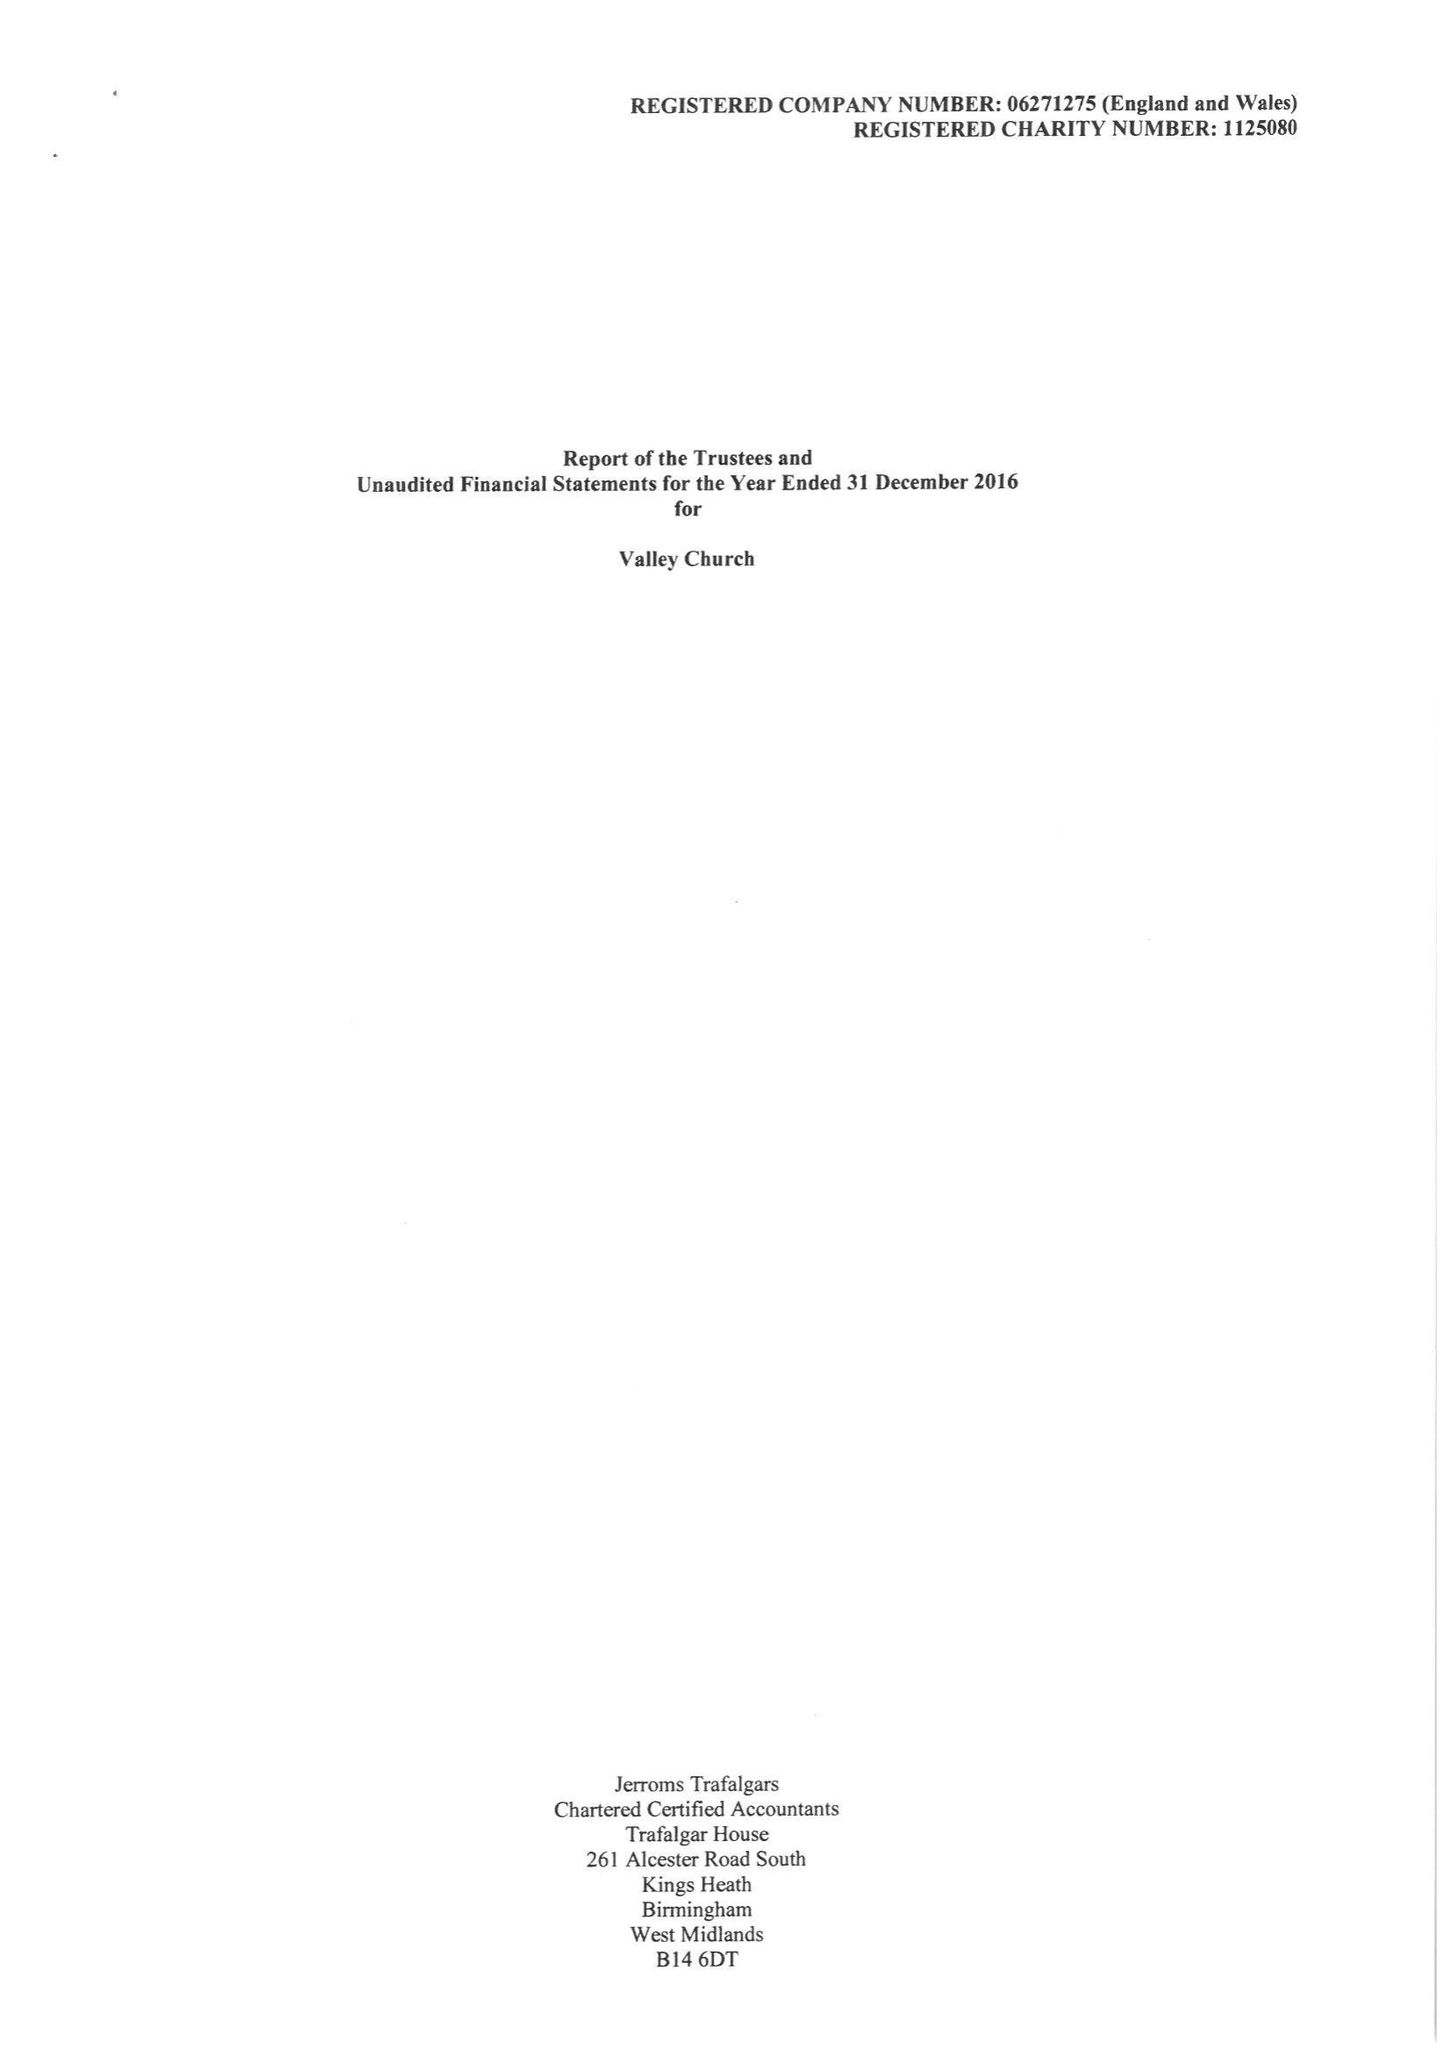What is the value for the charity_name?
Answer the question using a single word or phrase. Valley Church 